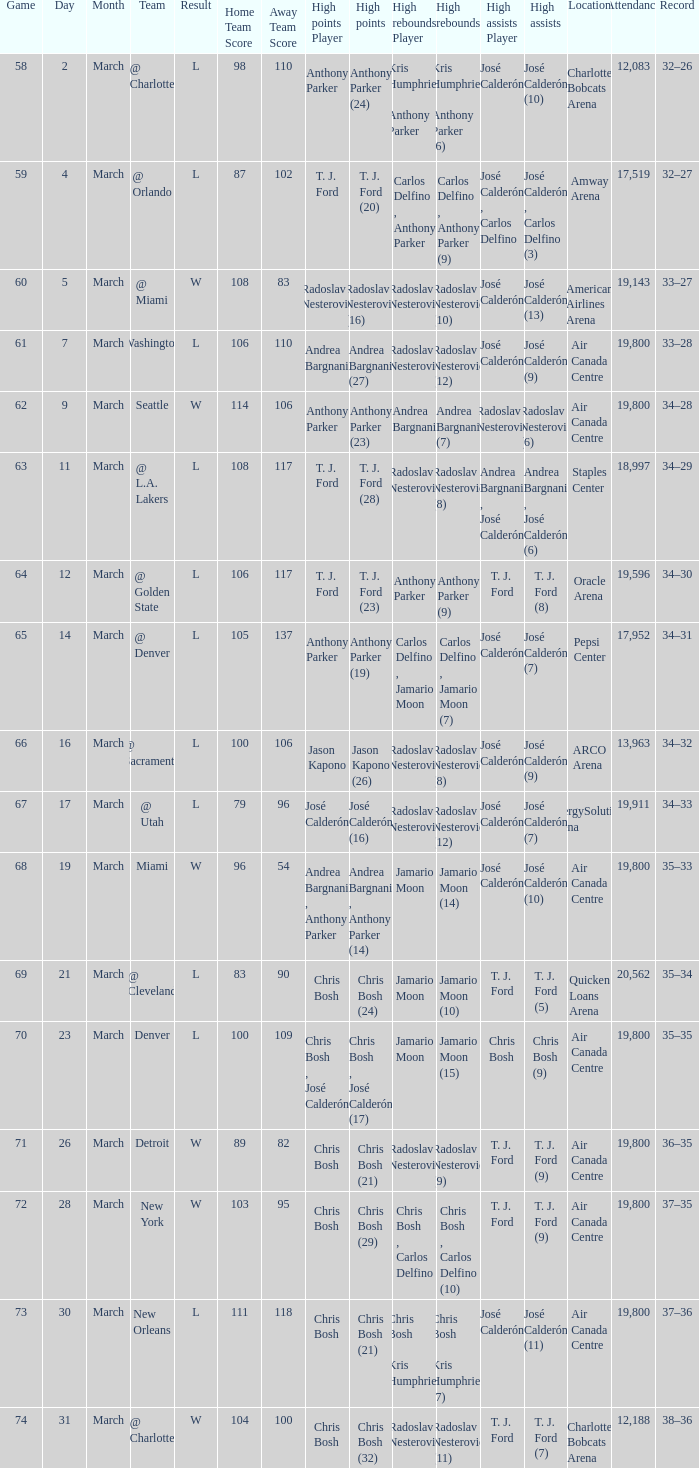Can you give me this table as a dict? {'header': ['Game', 'Day', 'Month', 'Team', 'Result', 'Home Team Score', 'Away Team Score', 'High points Player', 'High points', 'High rebounds Player', 'High rebounds', 'High assists Player', 'High assists', 'Location', 'Attendance', 'Record'], 'rows': [['58', '2', 'March', '@ Charlotte', 'L', '98', '110', 'Anthony Parker', 'Anthony Parker (24)', 'Kris Humphries , Anthony Parker', 'Kris Humphries , Anthony Parker (6)', 'José Calderón', 'José Calderón (10)', 'Charlotte Bobcats Arena', '12,083', '32–26'], ['59', '4', 'March', '@ Orlando', 'L', '87', '102', 'T. J. Ford', 'T. J. Ford (20)', 'Carlos Delfino , Anthony Parker', 'Carlos Delfino , Anthony Parker (9)', 'José Calderón , Carlos Delfino', 'José Calderón , Carlos Delfino (3)', 'Amway Arena', '17,519', '32–27'], ['60', '5', 'March', '@ Miami', 'W', '108', '83', 'Radoslav Nesterović', 'Radoslav Nesterović (16)', 'Radoslav Nesterović', 'Radoslav Nesterović (10)', 'José Calderón', 'José Calderón (13)', 'American Airlines Arena', '19,143', '33–27'], ['61', '7', 'March', 'Washington', 'L', '106', '110', 'Andrea Bargnani', 'Andrea Bargnani (27)', 'Radoslav Nesterović', 'Radoslav Nesterović (12)', 'José Calderón', 'José Calderón (9)', 'Air Canada Centre', '19,800', '33–28'], ['62', '9', 'March', 'Seattle', 'W', '114', '106', 'Anthony Parker', 'Anthony Parker (23)', 'Andrea Bargnani', 'Andrea Bargnani (7)', 'Radoslav Nesterović', 'Radoslav Nesterović (6)', 'Air Canada Centre', '19,800', '34–28'], ['63', '11', 'March', '@ L.A. Lakers', 'L', '108', '117', 'T. J. Ford', 'T. J. Ford (28)', 'Radoslav Nesterović', 'Radoslav Nesterović (8)', 'Andrea Bargnani , José Calderón', 'Andrea Bargnani , José Calderón (6)', 'Staples Center', '18,997', '34–29'], ['64', '12', 'March', '@ Golden State', 'L', '106', '117', 'T. J. Ford', 'T. J. Ford (23)', 'Anthony Parker', 'Anthony Parker (9)', 'T. J. Ford', 'T. J. Ford (8)', 'Oracle Arena', '19,596', '34–30'], ['65', '14', 'March', '@ Denver', 'L', '105', '137', 'Anthony Parker', 'Anthony Parker (19)', 'Carlos Delfino , Jamario Moon', 'Carlos Delfino , Jamario Moon (7)', 'José Calderón', 'José Calderón (7)', 'Pepsi Center', '17,952', '34–31'], ['66', '16', 'March', '@ Sacramento', 'L', '100', '106', 'Jason Kapono', 'Jason Kapono (26)', 'Radoslav Nesterović', 'Radoslav Nesterović (8)', 'José Calderón', 'José Calderón (9)', 'ARCO Arena', '13,963', '34–32'], ['67', '17', 'March', '@ Utah', 'L', '79', '96', 'José Calderón', 'José Calderón (16)', 'Radoslav Nesterović', 'Radoslav Nesterović (12)', 'José Calderón', 'José Calderón (7)', 'EnergySolutions Arena', '19,911', '34–33'], ['68', '19', 'March', 'Miami', 'W', '96', '54', 'Andrea Bargnani , Anthony Parker', 'Andrea Bargnani , Anthony Parker (14)', 'Jamario Moon', 'Jamario Moon (14)', 'José Calderón', 'José Calderón (10)', 'Air Canada Centre', '19,800', '35–33'], ['69', '21', 'March', '@ Cleveland', 'L', '83', '90', 'Chris Bosh', 'Chris Bosh (24)', 'Jamario Moon', 'Jamario Moon (10)', 'T. J. Ford', 'T. J. Ford (5)', 'Quicken Loans Arena', '20,562', '35–34'], ['70', '23', 'March', 'Denver', 'L', '100', '109', 'Chris Bosh , José Calderón', 'Chris Bosh , José Calderón (17)', 'Jamario Moon', 'Jamario Moon (15)', 'Chris Bosh', 'Chris Bosh (9)', 'Air Canada Centre', '19,800', '35–35'], ['71', '26', 'March', 'Detroit', 'W', '89', '82', 'Chris Bosh', 'Chris Bosh (21)', 'Radoslav Nesterović', 'Radoslav Nesterović (9)', 'T. J. Ford', 'T. J. Ford (9)', 'Air Canada Centre', '19,800', '36–35'], ['72', '28', 'March', 'New York', 'W', '103', '95', 'Chris Bosh', 'Chris Bosh (29)', 'Chris Bosh , Carlos Delfino', 'Chris Bosh , Carlos Delfino (10)', 'T. J. Ford', 'T. J. Ford (9)', 'Air Canada Centre', '19,800', '37–35'], ['73', '30', 'March', 'New Orleans', 'L', '111', '118', 'Chris Bosh', 'Chris Bosh (21)', 'Chris Bosh , Kris Humphries', 'Chris Bosh , Kris Humphries (7)', 'José Calderón', 'José Calderón (11)', 'Air Canada Centre', '19,800', '37–36'], ['74', '31', 'March', '@ Charlotte', 'W', '104', '100', 'Chris Bosh', 'Chris Bosh (32)', 'Radoslav Nesterović', 'Radoslav Nesterović (11)', 'T. J. Ford', 'T. J. Ford (7)', 'Charlotte Bobcats Arena', '12,188', '38–36']]} How many attended the game on march 16 after over 64 games? ARCO Arena 13,963. 